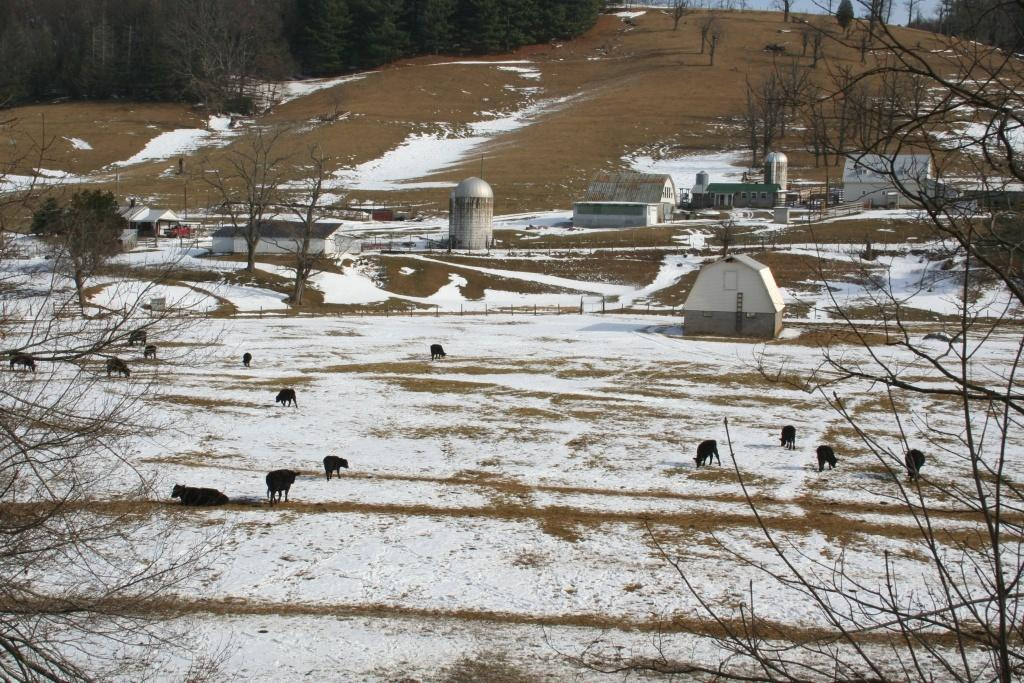What is the primary surface visible in the image? There is a ground in the picture. What is the condition of the ground? The ground has snow on it. What type of animals can be seen on the ground? There are animals present on the ground. What other elements can be seen in the picture? There are trees, houses, and the sky visible in the picture. How many beds are visible in the image? There are no beds visible in the image. 